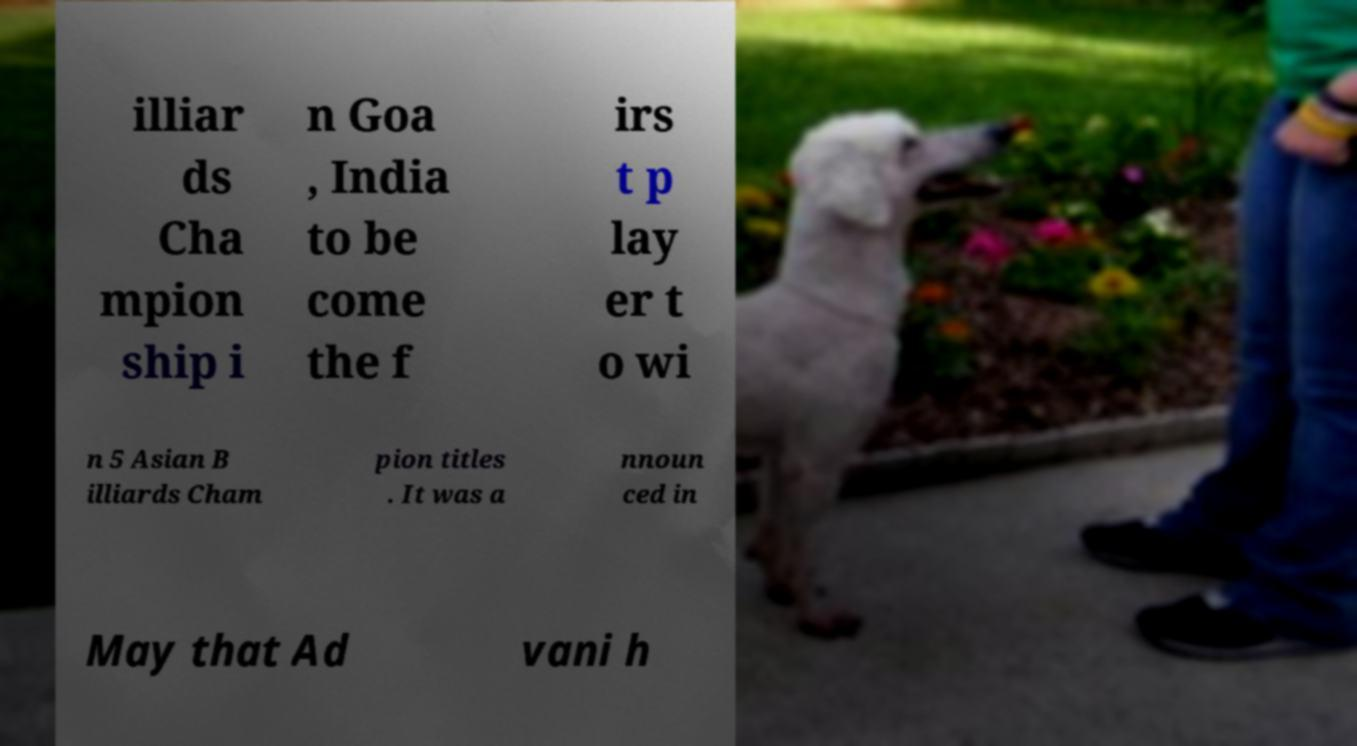There's text embedded in this image that I need extracted. Can you transcribe it verbatim? illiar ds Cha mpion ship i n Goa , India to be come the f irs t p lay er t o wi n 5 Asian B illiards Cham pion titles . It was a nnoun ced in May that Ad vani h 